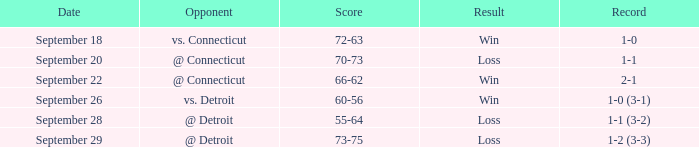What is the tally with a record of 1-0? 72-63. 